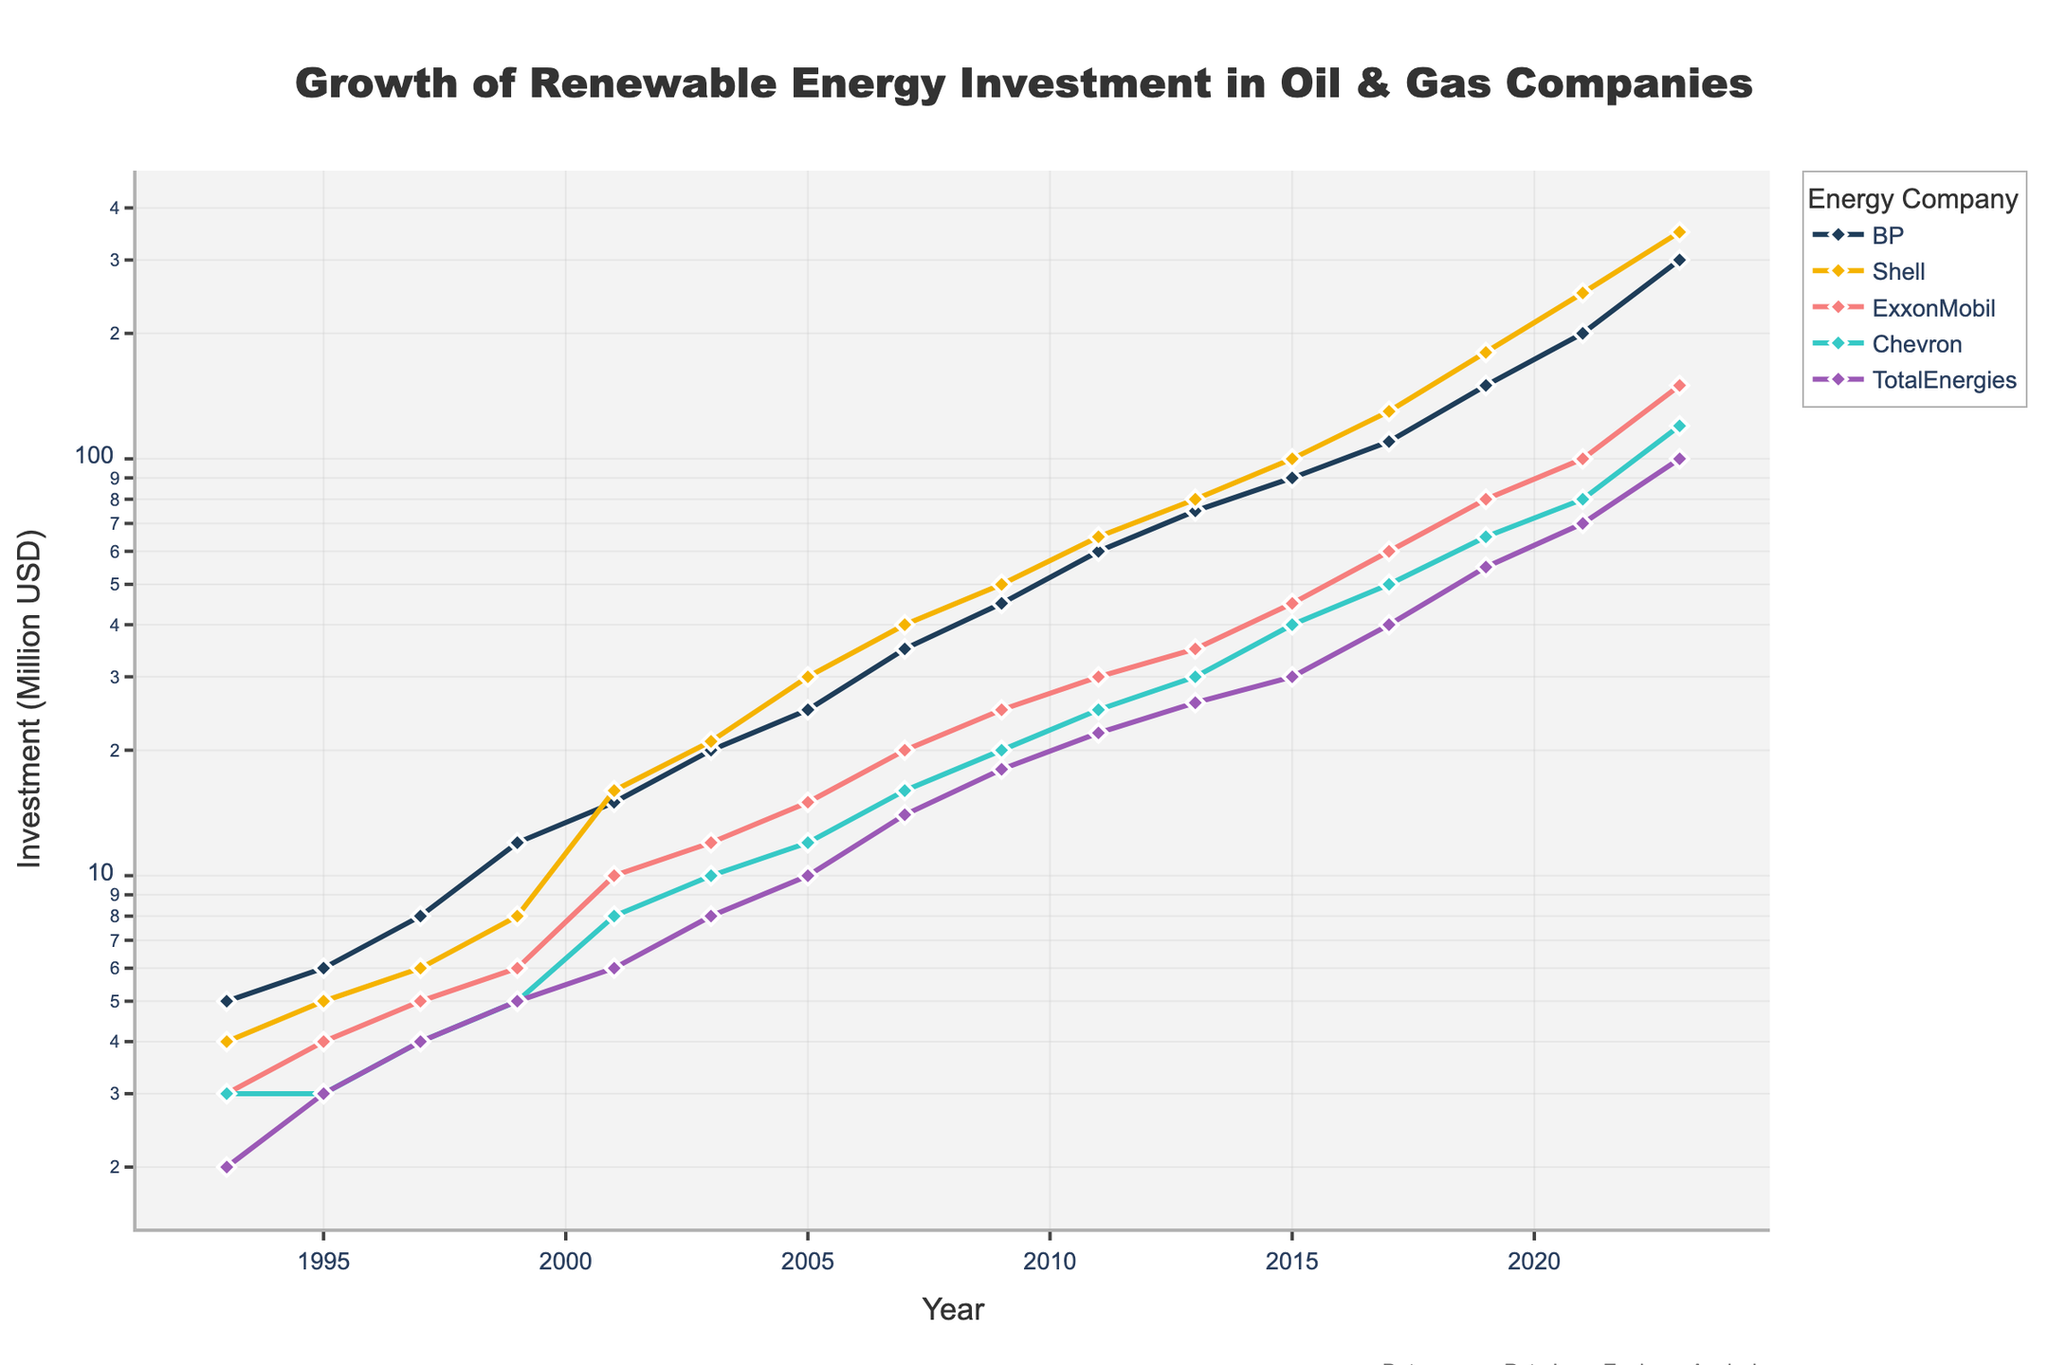What is the title of the plot? The title is usually placed at the top center of the plot. It summarizes the overall theme of the figure, making it easier to understand what the data is about. Here, it states the focus on renewable energy investment by oil and gas companies over time.
Answer: Growth of Renewable Energy Investment in Oil & Gas Companies What is the y-axis representing in the plot? The y-axis title typically describes what is being measured. In this case, it shows the amount of investment in renewable energy in million USD.
Answer: Investment (Million USD) Which company had the highest renewable energy investment in 2023? By locating the data points for the year 2023, we can compare the investments of various companies. The company with the highest y-value in 2023 has the maximum investment.
Answer: Shell How many companies are tracked in the plot? The legend of the plot usually lists all the companies included. The count of these items tells the number of companies tracked.
Answer: 5 What was the trend in investments for BP from 1993 to 2003? To identify the trend, observe the data points for BP within this time frame. The general direction of the points (upwards, downwards, or stable) indicates the trend. For BP, the investments are increasing, showing growth over this period.
Answer: Increasing What is the difference in investment for ExxonMobil between 2007 and 2023? Compare the data points for ExxonMobil in these two years. Subtract the investment value of 2007 from that of 2023 to find the difference.
Answer: 130 Million USD Which company started investing in renewable energy the earliest according to the plot? The x-axis represents time, with years listed from left to right. Identify the company associated with the earliest data point on the plot. BP's data point starts in 1993, making it the earliest.
Answer: BP How did the investment for Chevron change from 2009 to 2011? Locate Chevron's data points for these two years. The difference in the y-values will show the change. The investment increased from 25 million USD in 2009 to 30 million USD in 2011.
Answer: Increased What is the median investment value for TotalEnergies in the given time frame? List TotalEnergies' investment values in ascending order and find the middle value. The values are: 2, 8, 10, 14, 18, 22, 26, 30, 40, 55, 70, 100, with the median around the midpoint.
Answer: 22 Million USD In which year did Shell surpass BP in renewable energy investment? By examining the trend lines for Shell and BP, identify the year where Shell's investment first overtakes BP's. This occurs at the intersection point on the plot where Shell's line is above BP’s. This happens around 2001–2003.
Answer: 2001 